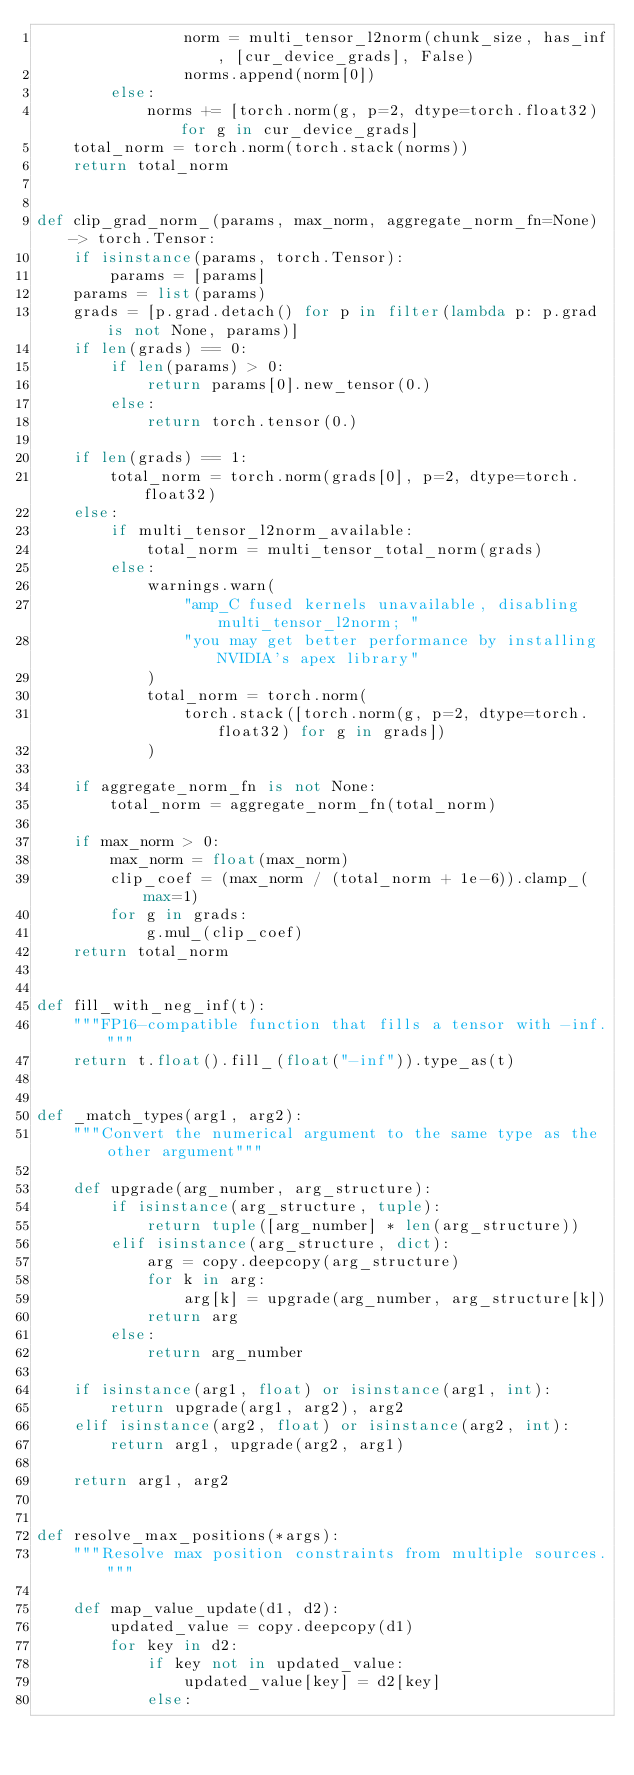<code> <loc_0><loc_0><loc_500><loc_500><_Python_>                norm = multi_tensor_l2norm(chunk_size, has_inf, [cur_device_grads], False)
                norms.append(norm[0])
        else:
            norms += [torch.norm(g, p=2, dtype=torch.float32) for g in cur_device_grads]
    total_norm = torch.norm(torch.stack(norms))
    return total_norm


def clip_grad_norm_(params, max_norm, aggregate_norm_fn=None) -> torch.Tensor:
    if isinstance(params, torch.Tensor):
        params = [params]
    params = list(params)
    grads = [p.grad.detach() for p in filter(lambda p: p.grad is not None, params)]
    if len(grads) == 0:
        if len(params) > 0:
            return params[0].new_tensor(0.)
        else:
            return torch.tensor(0.)

    if len(grads) == 1:
        total_norm = torch.norm(grads[0], p=2, dtype=torch.float32)
    else:
        if multi_tensor_l2norm_available:
            total_norm = multi_tensor_total_norm(grads)
        else:
            warnings.warn(
                "amp_C fused kernels unavailable, disabling multi_tensor_l2norm; "
                "you may get better performance by installing NVIDIA's apex library"
            )
            total_norm = torch.norm(
                torch.stack([torch.norm(g, p=2, dtype=torch.float32) for g in grads])
            )

    if aggregate_norm_fn is not None:
        total_norm = aggregate_norm_fn(total_norm)

    if max_norm > 0:
        max_norm = float(max_norm)
        clip_coef = (max_norm / (total_norm + 1e-6)).clamp_(max=1)
        for g in grads:
            g.mul_(clip_coef)
    return total_norm


def fill_with_neg_inf(t):
    """FP16-compatible function that fills a tensor with -inf."""
    return t.float().fill_(float("-inf")).type_as(t)


def _match_types(arg1, arg2):
    """Convert the numerical argument to the same type as the other argument"""

    def upgrade(arg_number, arg_structure):
        if isinstance(arg_structure, tuple):
            return tuple([arg_number] * len(arg_structure))
        elif isinstance(arg_structure, dict):
            arg = copy.deepcopy(arg_structure)
            for k in arg:
                arg[k] = upgrade(arg_number, arg_structure[k])
            return arg
        else:
            return arg_number

    if isinstance(arg1, float) or isinstance(arg1, int):
        return upgrade(arg1, arg2), arg2
    elif isinstance(arg2, float) or isinstance(arg2, int):
        return arg1, upgrade(arg2, arg1)

    return arg1, arg2


def resolve_max_positions(*args):
    """Resolve max position constraints from multiple sources."""

    def map_value_update(d1, d2):
        updated_value = copy.deepcopy(d1)
        for key in d2:
            if key not in updated_value:
                updated_value[key] = d2[key]
            else:</code> 